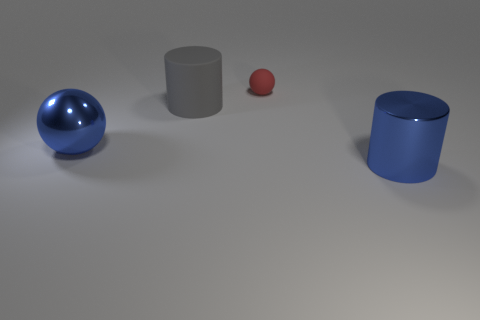There is a big shiny thing that is the same color as the shiny cylinder; what shape is it?
Offer a terse response. Sphere. Is there a metallic object of the same color as the metal cylinder?
Keep it short and to the point. Yes. What size is the metallic thing that is the same color as the large shiny cylinder?
Your answer should be compact. Large. There is a shiny object that is on the right side of the blue thing that is to the left of the metal thing that is right of the red rubber object; what shape is it?
Make the answer very short. Cylinder. What number of other objects are there of the same shape as the small object?
Your answer should be very brief. 1. There is a big object that is in front of the large blue object on the left side of the big gray object; what is it made of?
Keep it short and to the point. Metal. Is there any other thing that is the same size as the red sphere?
Ensure brevity in your answer.  No. Is the material of the big gray cylinder the same as the sphere that is to the right of the large blue metallic sphere?
Make the answer very short. Yes. There is a thing that is both in front of the large matte thing and on the right side of the blue ball; what is it made of?
Give a very brief answer. Metal. There is a large metallic thing that is left of the thing that is in front of the metal sphere; what is its color?
Make the answer very short. Blue. 